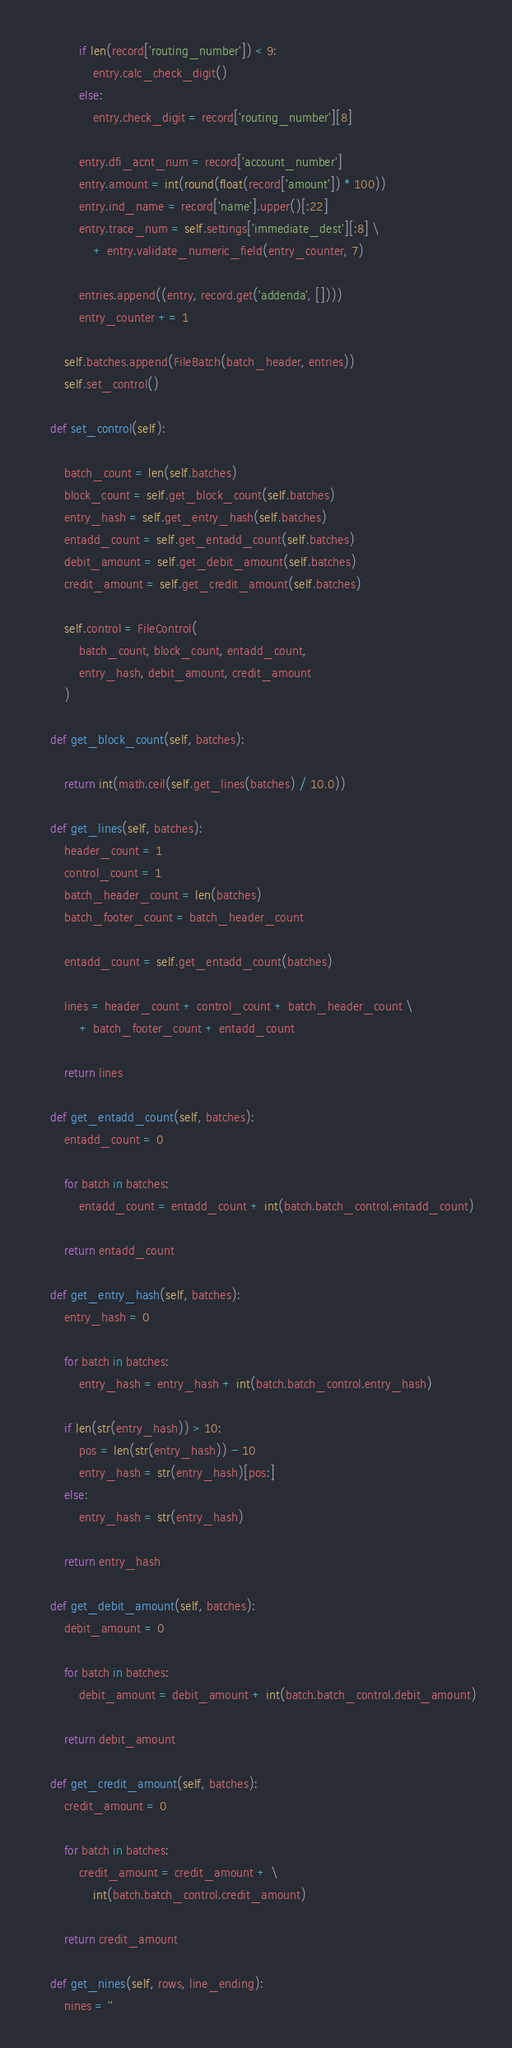Convert code to text. <code><loc_0><loc_0><loc_500><loc_500><_Python_>            if len(record['routing_number']) < 9:
                entry.calc_check_digit()
            else:
                entry.check_digit = record['routing_number'][8]

            entry.dfi_acnt_num = record['account_number']
            entry.amount = int(round(float(record['amount']) * 100))
            entry.ind_name = record['name'].upper()[:22]
            entry.trace_num = self.settings['immediate_dest'][:8] \
                + entry.validate_numeric_field(entry_counter, 7)

            entries.append((entry, record.get('addenda', [])))
            entry_counter += 1

        self.batches.append(FileBatch(batch_header, entries))
        self.set_control()

    def set_control(self):

        batch_count = len(self.batches)
        block_count = self.get_block_count(self.batches)
        entry_hash = self.get_entry_hash(self.batches)
        entadd_count = self.get_entadd_count(self.batches)
        debit_amount = self.get_debit_amount(self.batches)
        credit_amount = self.get_credit_amount(self.batches)

        self.control = FileControl(
            batch_count, block_count, entadd_count,
            entry_hash, debit_amount, credit_amount
        )

    def get_block_count(self, batches):

        return int(math.ceil(self.get_lines(batches) / 10.0))

    def get_lines(self, batches):
        header_count = 1
        control_count = 1
        batch_header_count = len(batches)
        batch_footer_count = batch_header_count

        entadd_count = self.get_entadd_count(batches)

        lines = header_count + control_count + batch_header_count \
            + batch_footer_count + entadd_count

        return lines

    def get_entadd_count(self, batches):
        entadd_count = 0

        for batch in batches:
            entadd_count = entadd_count + int(batch.batch_control.entadd_count)

        return entadd_count

    def get_entry_hash(self, batches):
        entry_hash = 0

        for batch in batches:
            entry_hash = entry_hash + int(batch.batch_control.entry_hash)

        if len(str(entry_hash)) > 10:
            pos = len(str(entry_hash)) - 10
            entry_hash = str(entry_hash)[pos:]
        else:
            entry_hash = str(entry_hash)

        return entry_hash

    def get_debit_amount(self, batches):
        debit_amount = 0

        for batch in batches:
            debit_amount = debit_amount + int(batch.batch_control.debit_amount)

        return debit_amount

    def get_credit_amount(self, batches):
        credit_amount = 0

        for batch in batches:
            credit_amount = credit_amount + \
                int(batch.batch_control.credit_amount)

        return credit_amount

    def get_nines(self, rows, line_ending):
        nines = ''
</code> 